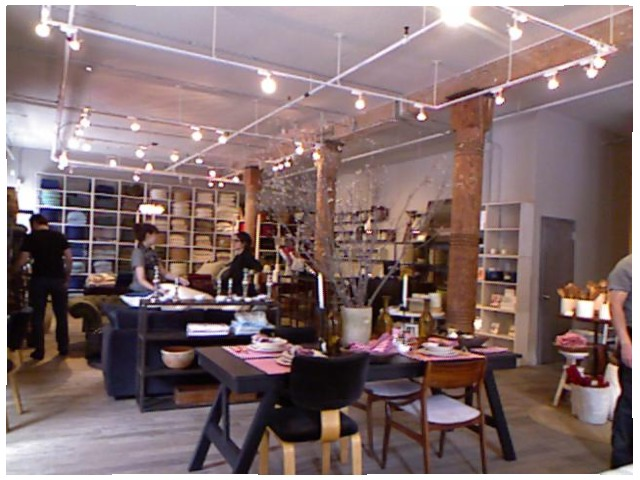<image>
Can you confirm if the soup bowl is on the pink tablecloth? Yes. Looking at the image, I can see the soup bowl is positioned on top of the pink tablecloth, with the pink tablecloth providing support. Where is the lights in relation to the ceiling? Is it on the ceiling? Yes. Looking at the image, I can see the lights is positioned on top of the ceiling, with the ceiling providing support. 